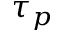Convert formula to latex. <formula><loc_0><loc_0><loc_500><loc_500>\tau _ { p }</formula> 